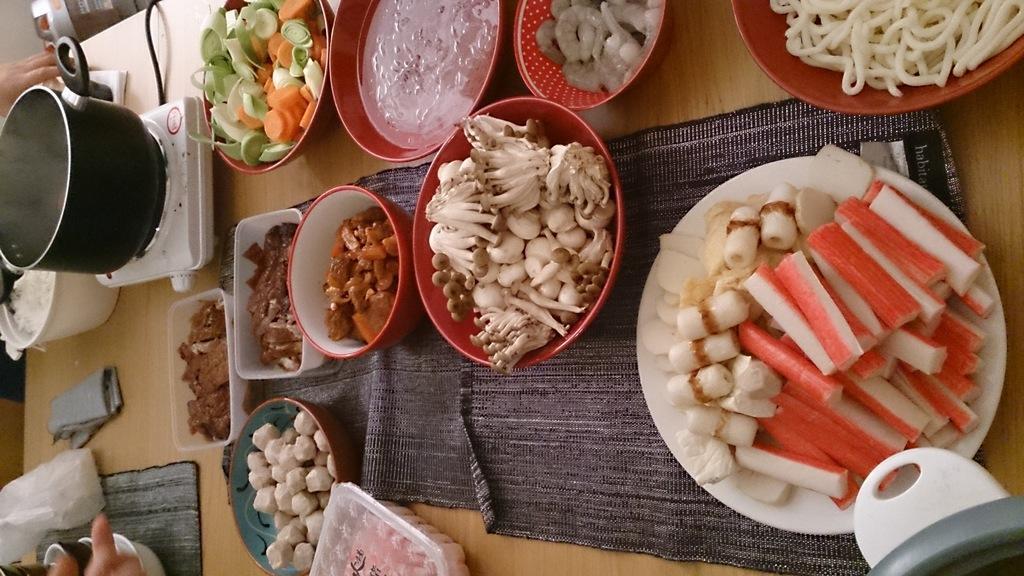In one or two sentences, can you explain what this image depicts? In this image there are objects on the surface, there are bowls, there is a plate, there is food in the plate, there is food in the bowl,there is a bowl truncated towards the right of the image, there is an object truncated towards the right of the image, there is an object truncated towards the bottom of the image, there are objects truncated towards the left of the image, there are is a person hand truncated towards the left of the image, there are is a person hand truncated towards the bottom of the image. 